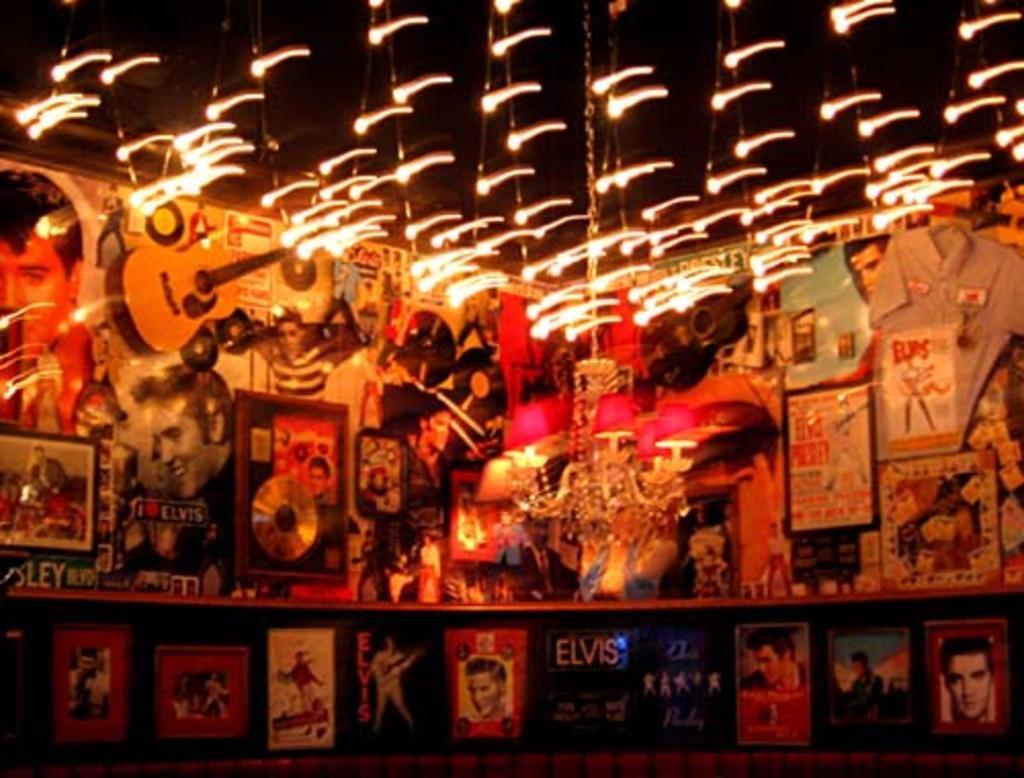Can you describe this image briefly? These are the lights, at the top there are different photographs in the middle of an image. 